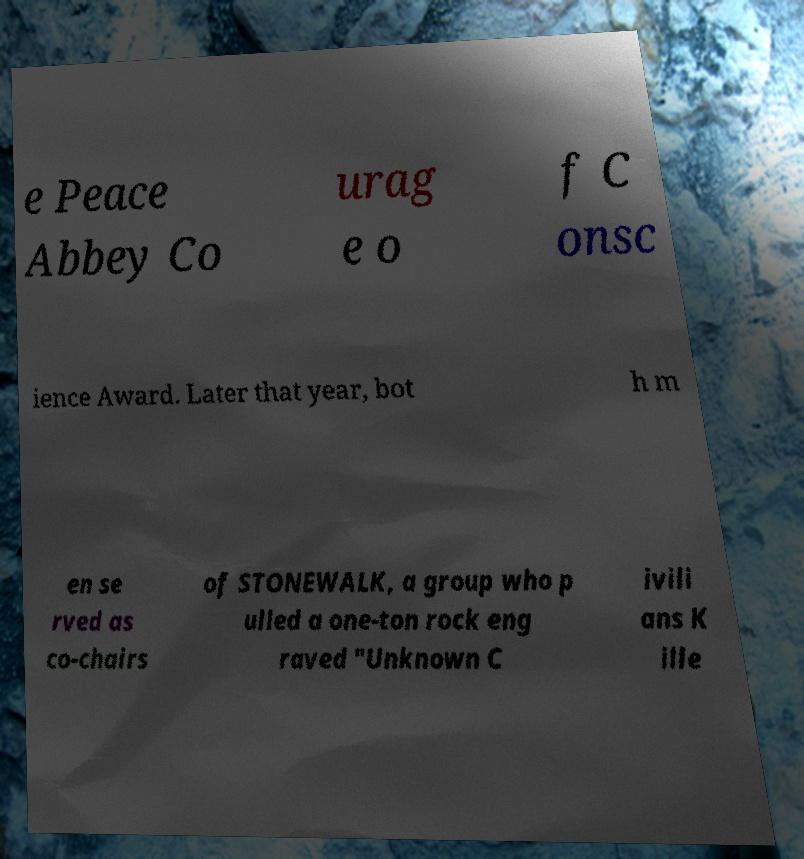Can you read and provide the text displayed in the image?This photo seems to have some interesting text. Can you extract and type it out for me? e Peace Abbey Co urag e o f C onsc ience Award. Later that year, bot h m en se rved as co-chairs of STONEWALK, a group who p ulled a one-ton rock eng raved "Unknown C ivili ans K ille 